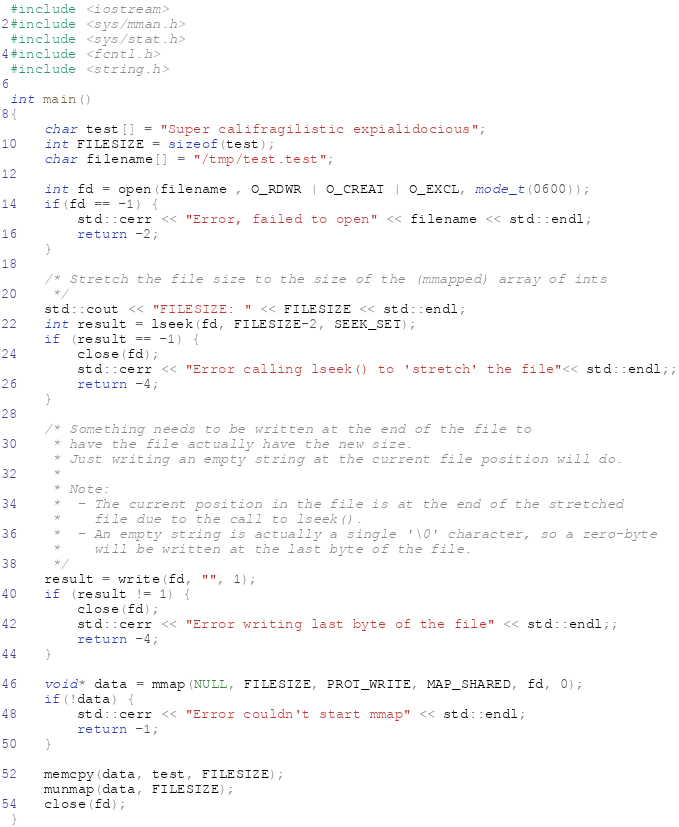Convert code to text. <code><loc_0><loc_0><loc_500><loc_500><_C++_>#include <iostream>
#include <sys/mman.h>
#include <sys/stat.h>
#include <fcntl.h>
#include <string.h>

int main()
{
    char test[] = "Super califragilistic expialidocious";
    int FILESIZE = sizeof(test);
    char filename[] = "/tmp/test.test";
    
    int fd = open(filename , O_RDWR | O_CREAT | O_EXCL, mode_t(0600));
    if(fd == -1) {
        std::cerr << "Error, failed to open" << filename << std::endl;
        return -2;
    }  

    /* Stretch the file size to the size of the (mmapped) array of ints
     */
    std::cout << "FILESIZE: " << FILESIZE << std::endl;
    int result = lseek(fd, FILESIZE-2, SEEK_SET);
    if (result == -1) {
        close(fd);
        std::cerr << "Error calling lseek() to 'stretch' the file"<< std::endl;;
        return -4;
    }

    /* Something needs to be written at the end of the file to
     * have the file actually have the new size.
     * Just writing an empty string at the current file position will do.
     *
     * Note:
     *  - The current position in the file is at the end of the stretched 
     *    file due to the call to lseek().
     *  - An empty string is actually a single '\0' character, so a zero-byte
     *    will be written at the last byte of the file.
     */
    result = write(fd, "", 1);
    if (result != 1) {
        close(fd);
        std::cerr << "Error writing last byte of the file" << std::endl;;
        return -4;
    }

    void* data = mmap(NULL, FILESIZE, PROT_WRITE, MAP_SHARED, fd, 0);
    if(!data) {
        std::cerr << "Error couldn't start mmap" << std::endl;
        return -1;
    }
    
    memcpy(data, test, FILESIZE);
    munmap(data, FILESIZE);
    close(fd);
}
</code> 